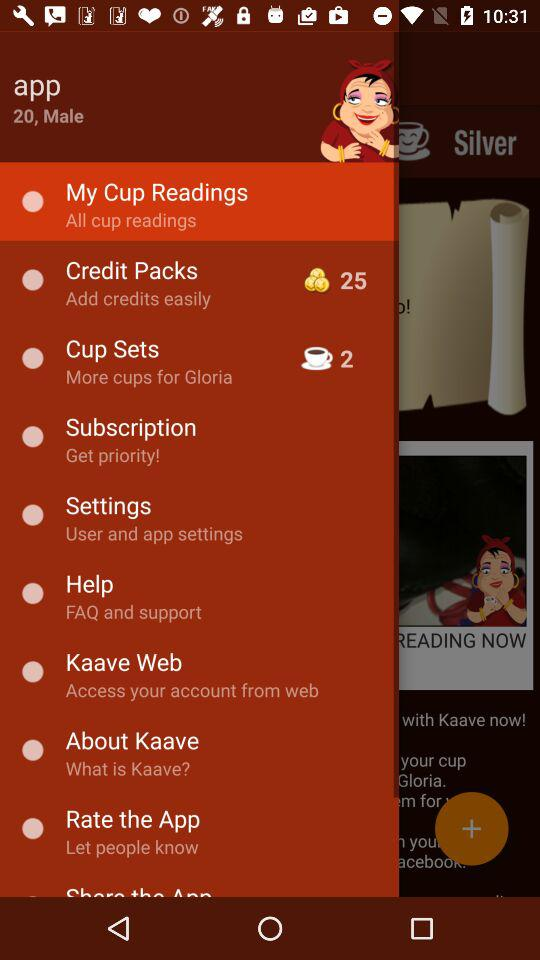What is the age of the App? The age is 20 years. 